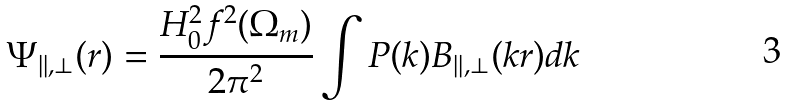Convert formula to latex. <formula><loc_0><loc_0><loc_500><loc_500>\Psi _ { | | , \perp } ( r ) = \frac { H _ { 0 } ^ { 2 } f ^ { 2 } ( \Omega _ { m } ) } { 2 \pi ^ { 2 } } \int P ( k ) B _ { | | , \perp } ( k r ) d k</formula> 